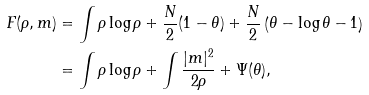Convert formula to latex. <formula><loc_0><loc_0><loc_500><loc_500>F ( \rho , m ) & = \int \rho \log \rho + \frac { N } 2 ( 1 - \theta ) + \frac { N } 2 \left ( \theta - \log \theta - 1 \right ) \\ & = \int \rho \log \rho + \int \frac { | m | ^ { 2 } } { 2 \rho } + \Psi ( \theta ) ,</formula> 